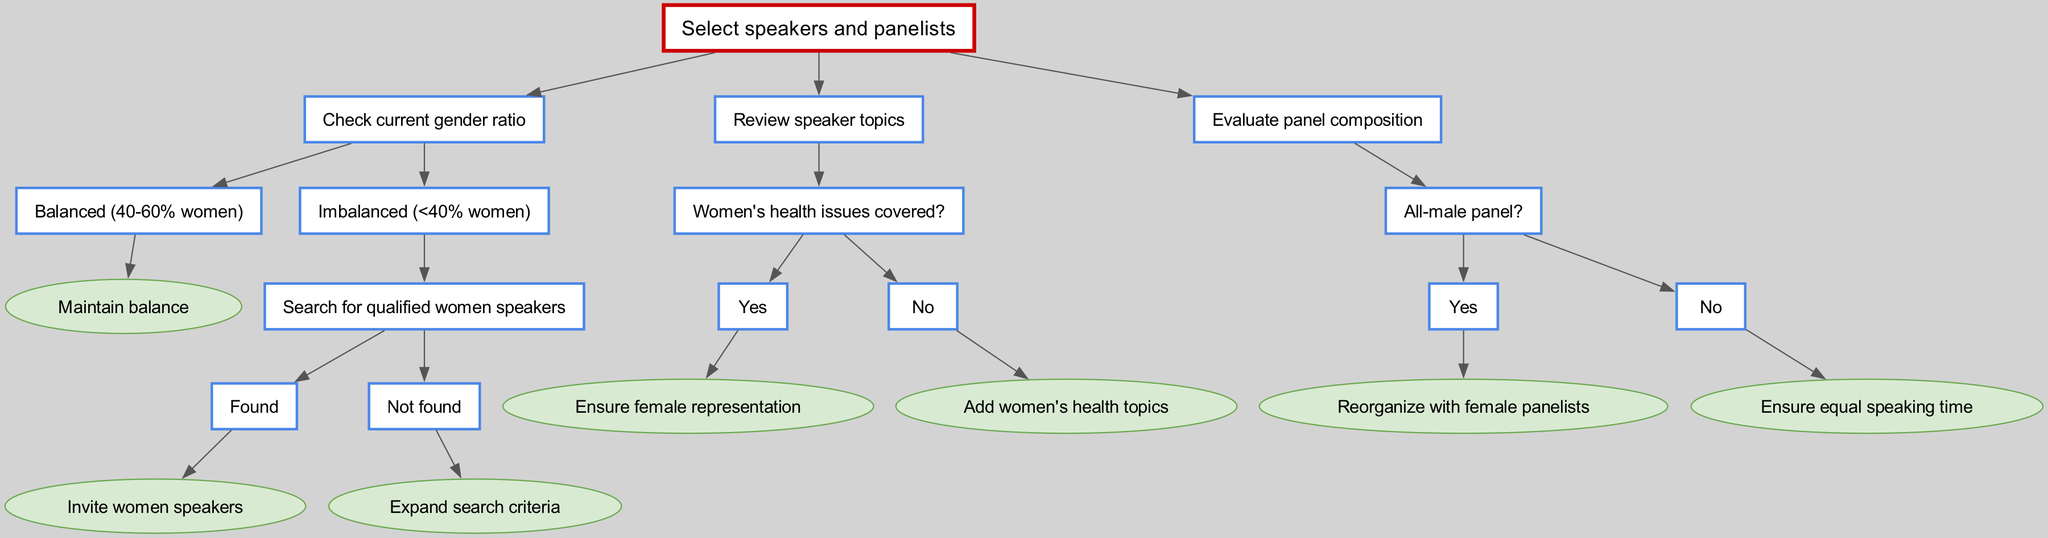What is the root node of the decision tree? The root node is the initial point of the decision-making process. According to the diagram, it states, "Select speakers and panelists."
Answer: Select speakers and panelists How many main branches are in the decision tree? The decision tree has three main branches originating from the root node. These branches address checking the gender ratio, reviewing speaker topics, and evaluating panel composition.
Answer: Three What is the outcome if the gender ratio is <40% women? If the gender ratio is less than 40% women, the next step in the flow is to "Search for qualified women speakers." The outcome of this search leads to either inviting women speakers or expanding search criteria.
Answer: Search for qualified women speakers What happens if all panelists are male? If the panel composition is all male, the diagram indicates the next action is to "Reorganize with female panelists." This ensures that gender diversity is addressed in the panel discussion.
Answer: Reorganize with female panelists Is there a decision based on whether women's health issues are covered? Yes, the decision tree explicitly includes a branch to determine if women's health issues are covered. If they are covered, the response is to "Ensure female representation," whereas if not, the step is to "Add women's health topics."
Answer: Yes What should be done if no qualified women speakers are found? If no qualified women speakers are found, the recommended action is to "Expand search criteria," suggesting a broader approach to finding suitable female speakers.
Answer: Expand search criteria What is the consequence of a balanced gender ratio in the selection process? If the gender ratio is balanced, within the range of 40-60% women, the decision tree states to "Maintain balance," indicating that no action is needed to adjust the representation further.
Answer: Maintain balance How is equal speaking time ensured in the panel? The decision tree stipulates that if the panel composition is not all male, the next focus is on ensuring "equal speaking time," reflecting the importance of equity in panel discussions.
Answer: Ensure equal speaking time What internal evaluation occurs regarding speaker topics? The diagram includes a decision point on whether women's health issues are covered among the speaker topics. Depending on the answer, actions are taken to either ensure representation or add topics.
Answer: Women's health issues covered 